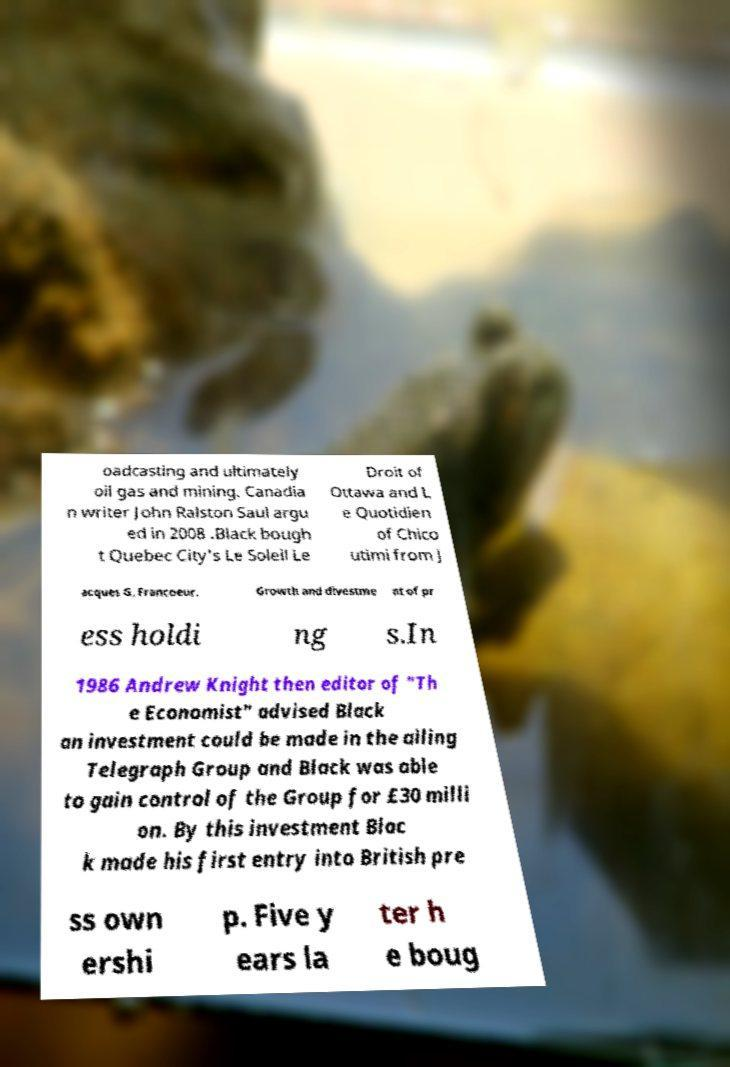Could you extract and type out the text from this image? oadcasting and ultimately oil gas and mining. Canadia n writer John Ralston Saul argu ed in 2008 .Black bough t Quebec City's Le Soleil Le Droit of Ottawa and L e Quotidien of Chico utimi from J acques G. Francoeur. Growth and divestme nt of pr ess holdi ng s.In 1986 Andrew Knight then editor of "Th e Economist" advised Black an investment could be made in the ailing Telegraph Group and Black was able to gain control of the Group for £30 milli on. By this investment Blac k made his first entry into British pre ss own ershi p. Five y ears la ter h e boug 